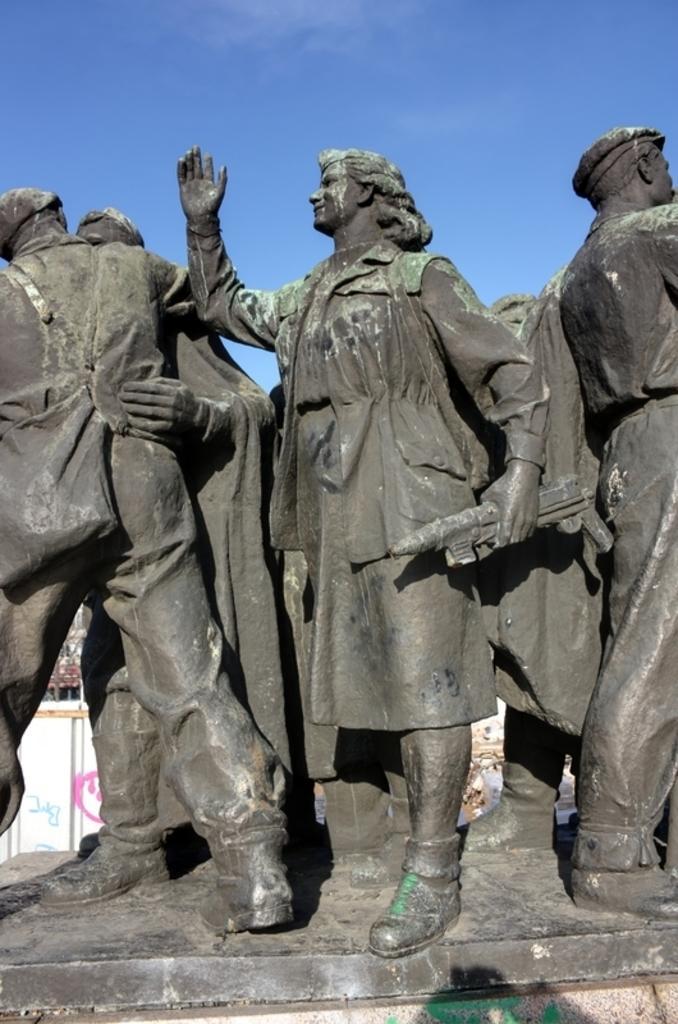Could you give a brief overview of what you see in this image? In this picture I can see number of statues in front and in the background I see the blue sky. 